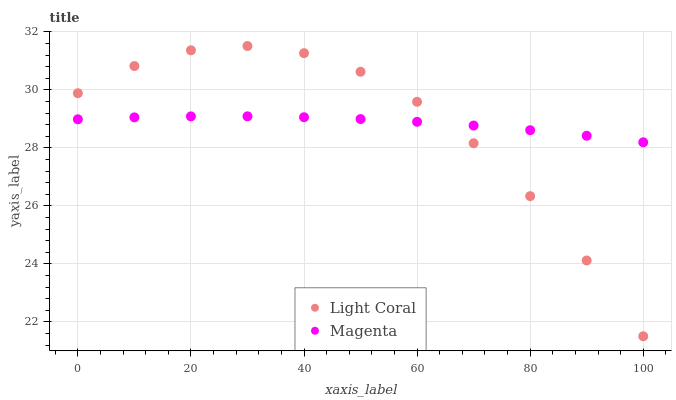Does Magenta have the minimum area under the curve?
Answer yes or no. Yes. Does Light Coral have the maximum area under the curve?
Answer yes or no. Yes. Does Magenta have the maximum area under the curve?
Answer yes or no. No. Is Magenta the smoothest?
Answer yes or no. Yes. Is Light Coral the roughest?
Answer yes or no. Yes. Is Magenta the roughest?
Answer yes or no. No. Does Light Coral have the lowest value?
Answer yes or no. Yes. Does Magenta have the lowest value?
Answer yes or no. No. Does Light Coral have the highest value?
Answer yes or no. Yes. Does Magenta have the highest value?
Answer yes or no. No. Does Light Coral intersect Magenta?
Answer yes or no. Yes. Is Light Coral less than Magenta?
Answer yes or no. No. Is Light Coral greater than Magenta?
Answer yes or no. No. 